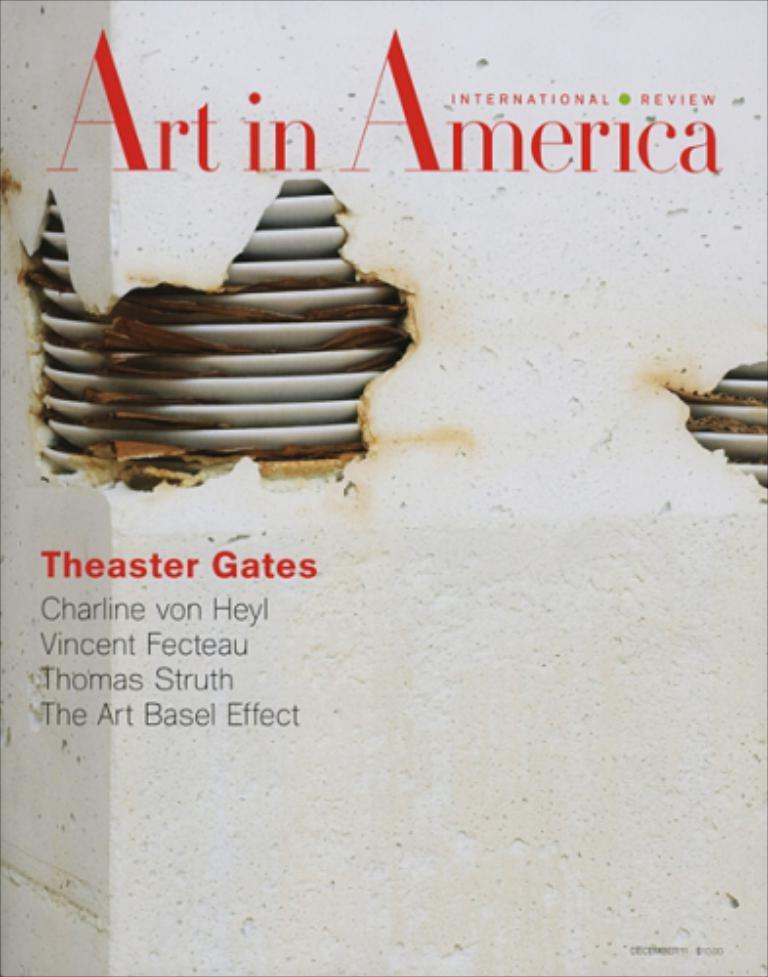What is present on the metal object in the image? There is a poster on the metal object in the image. What can be found on the poster? There is text on the poster. What type of coach can be seen in the image? There is no coach present in the image; it only features a poster on a metal object with text. How many fowl are visible in the image? There are no fowl present in the image. 